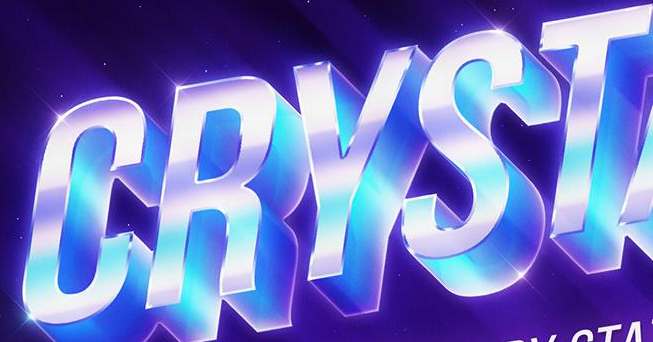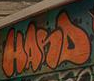What text is displayed in these images sequentially, separated by a semicolon? CRYST; HANS 